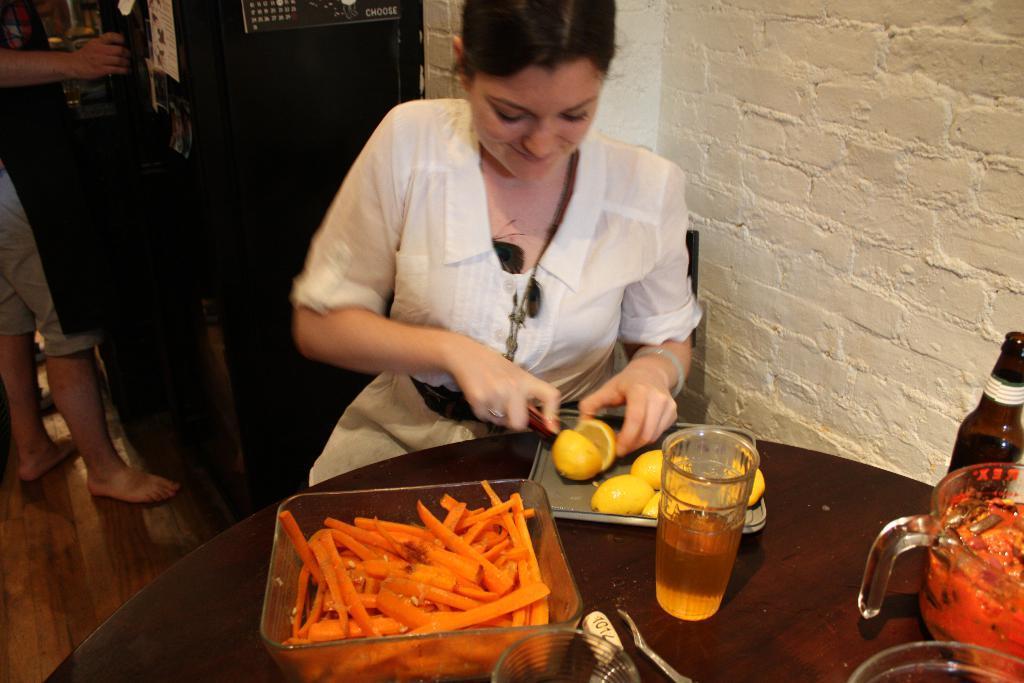Please provide a concise description of this image. In this picture there is a lady who is sitting at the center of the image and there is a table in front of her, on which glass bottle, glass, jar and spoon and there are carrot slices in the tray on the table and the lady is cutting the lemon, there is a person who is standing at the left side of the image. 